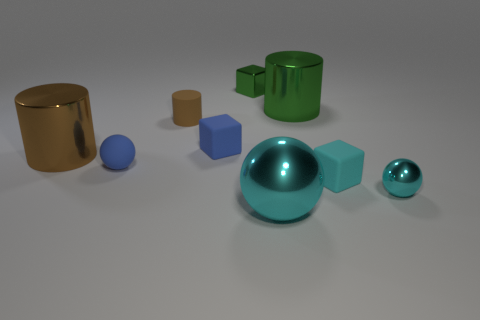Subtract all brown cubes. How many brown cylinders are left? 2 Subtract all small balls. How many balls are left? 1 Subtract 1 cylinders. How many cylinders are left? 2 Add 1 blue shiny balls. How many objects exist? 10 Subtract all balls. How many objects are left? 6 Subtract 1 cyan balls. How many objects are left? 8 Subtract all purple spheres. Subtract all purple cylinders. How many spheres are left? 3 Subtract all cyan metallic spheres. Subtract all tiny green metallic blocks. How many objects are left? 6 Add 5 small cyan spheres. How many small cyan spheres are left? 6 Add 9 tiny purple metal blocks. How many tiny purple metal blocks exist? 9 